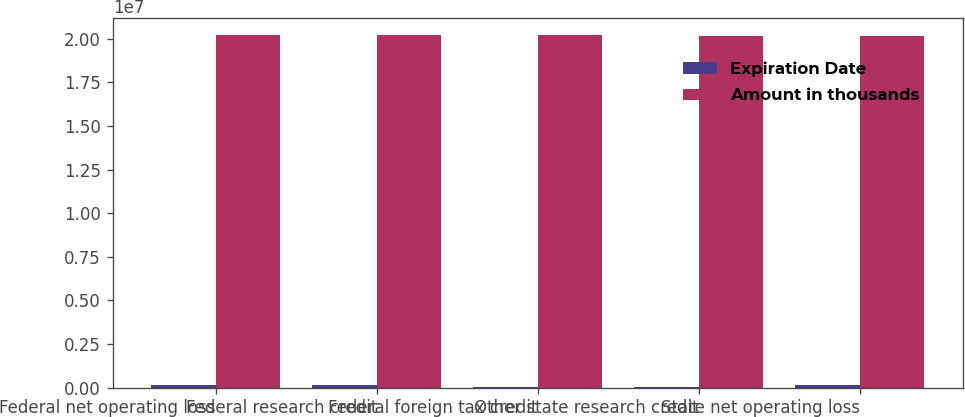Convert chart. <chart><loc_0><loc_0><loc_500><loc_500><stacked_bar_chart><ecel><fcel>Federal net operating loss<fcel>Federal research credit<fcel>Federal foreign tax credit<fcel>Other state research credit<fcel>State net operating loss<nl><fcel>Expiration Date<fcel>162289<fcel>126649<fcel>13557<fcel>8074<fcel>159496<nl><fcel>Amount in thousands<fcel>2.0182e+07<fcel>2.0182e+07<fcel>2.0182e+07<fcel>2.0152e+07<fcel>2.0152e+07<nl></chart> 